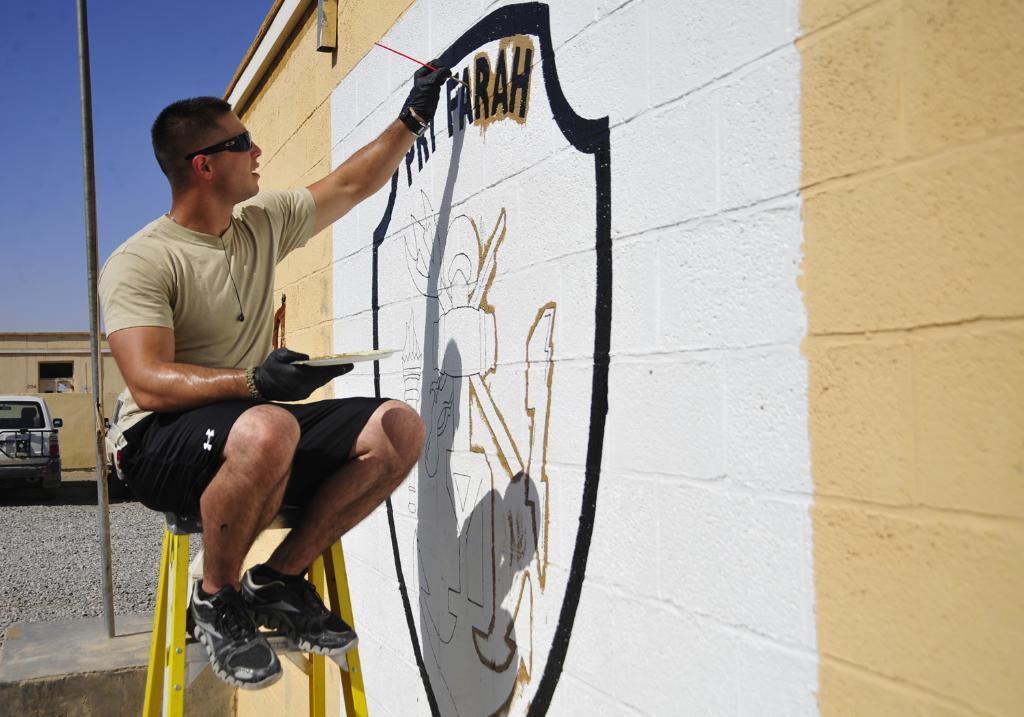Describe this image in one or two sentences. In this image we can see a man sitting on a stool holding a plate and a paint brush. We can also see a wall with some painting on it, a pole, stones, a car, a building and the sky which looks cloudy. 